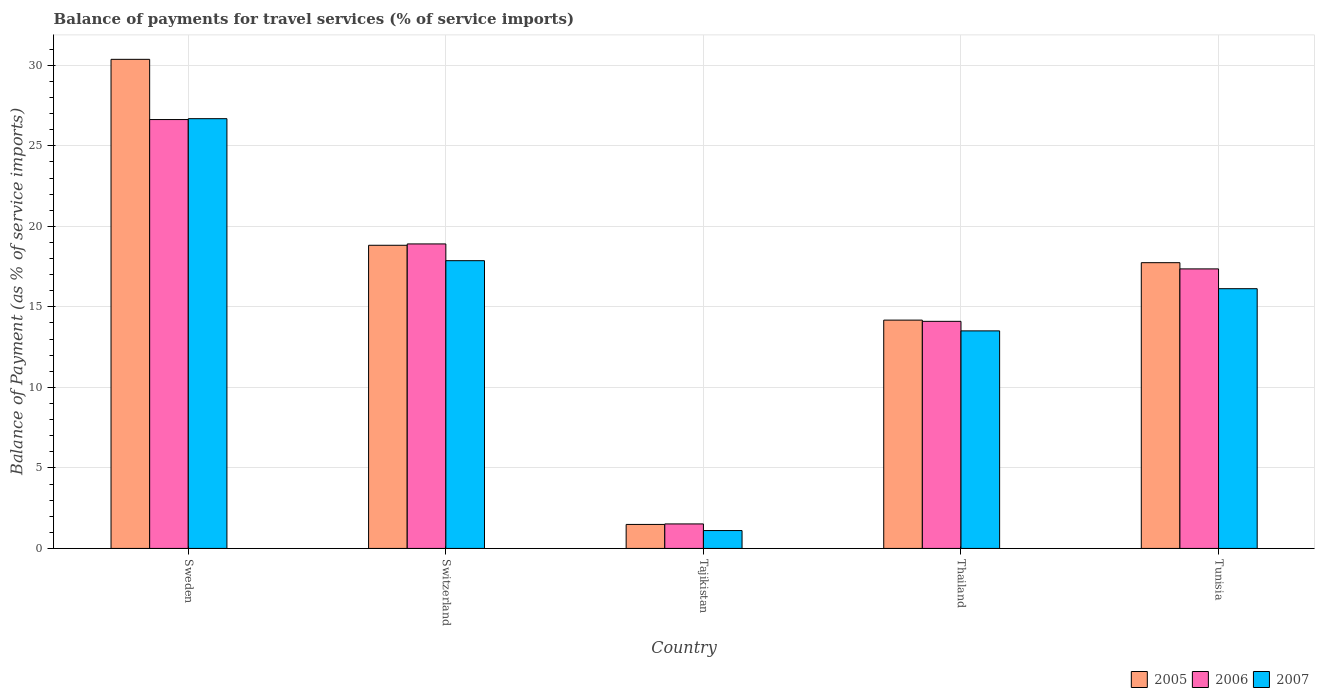How many different coloured bars are there?
Keep it short and to the point. 3. How many groups of bars are there?
Your answer should be very brief. 5. Are the number of bars on each tick of the X-axis equal?
Your response must be concise. Yes. How many bars are there on the 1st tick from the right?
Your response must be concise. 3. What is the label of the 1st group of bars from the left?
Provide a succinct answer. Sweden. What is the balance of payments for travel services in 2005 in Sweden?
Provide a succinct answer. 30.37. Across all countries, what is the maximum balance of payments for travel services in 2005?
Your response must be concise. 30.37. Across all countries, what is the minimum balance of payments for travel services in 2006?
Keep it short and to the point. 1.52. In which country was the balance of payments for travel services in 2006 maximum?
Your answer should be very brief. Sweden. In which country was the balance of payments for travel services in 2007 minimum?
Ensure brevity in your answer.  Tajikistan. What is the total balance of payments for travel services in 2005 in the graph?
Offer a very short reply. 82.62. What is the difference between the balance of payments for travel services in 2005 in Sweden and that in Tunisia?
Offer a very short reply. 12.63. What is the difference between the balance of payments for travel services in 2006 in Tunisia and the balance of payments for travel services in 2007 in Tajikistan?
Offer a terse response. 16.25. What is the average balance of payments for travel services in 2005 per country?
Your response must be concise. 16.52. What is the difference between the balance of payments for travel services of/in 2005 and balance of payments for travel services of/in 2007 in Thailand?
Your answer should be compact. 0.67. What is the ratio of the balance of payments for travel services in 2006 in Thailand to that in Tunisia?
Offer a terse response. 0.81. What is the difference between the highest and the second highest balance of payments for travel services in 2005?
Your response must be concise. -1.08. What is the difference between the highest and the lowest balance of payments for travel services in 2007?
Make the answer very short. 25.58. In how many countries, is the balance of payments for travel services in 2007 greater than the average balance of payments for travel services in 2007 taken over all countries?
Make the answer very short. 3. Is the sum of the balance of payments for travel services in 2006 in Sweden and Tajikistan greater than the maximum balance of payments for travel services in 2005 across all countries?
Ensure brevity in your answer.  No. What does the 1st bar from the left in Tunisia represents?
Give a very brief answer. 2005. What does the 1st bar from the right in Tunisia represents?
Provide a short and direct response. 2007. How many bars are there?
Make the answer very short. 15. Are all the bars in the graph horizontal?
Provide a succinct answer. No. How many countries are there in the graph?
Provide a short and direct response. 5. What is the difference between two consecutive major ticks on the Y-axis?
Give a very brief answer. 5. Does the graph contain any zero values?
Offer a very short reply. No. Does the graph contain grids?
Make the answer very short. Yes. Where does the legend appear in the graph?
Give a very brief answer. Bottom right. What is the title of the graph?
Your response must be concise. Balance of payments for travel services (% of service imports). What is the label or title of the Y-axis?
Provide a succinct answer. Balance of Payment (as % of service imports). What is the Balance of Payment (as % of service imports) in 2005 in Sweden?
Give a very brief answer. 30.37. What is the Balance of Payment (as % of service imports) of 2006 in Sweden?
Keep it short and to the point. 26.63. What is the Balance of Payment (as % of service imports) of 2007 in Sweden?
Keep it short and to the point. 26.69. What is the Balance of Payment (as % of service imports) in 2005 in Switzerland?
Ensure brevity in your answer.  18.83. What is the Balance of Payment (as % of service imports) of 2006 in Switzerland?
Provide a succinct answer. 18.91. What is the Balance of Payment (as % of service imports) of 2007 in Switzerland?
Your answer should be very brief. 17.87. What is the Balance of Payment (as % of service imports) of 2005 in Tajikistan?
Offer a very short reply. 1.49. What is the Balance of Payment (as % of service imports) in 2006 in Tajikistan?
Ensure brevity in your answer.  1.52. What is the Balance of Payment (as % of service imports) in 2007 in Tajikistan?
Offer a terse response. 1.11. What is the Balance of Payment (as % of service imports) of 2005 in Thailand?
Offer a terse response. 14.18. What is the Balance of Payment (as % of service imports) in 2006 in Thailand?
Ensure brevity in your answer.  14.1. What is the Balance of Payment (as % of service imports) of 2007 in Thailand?
Make the answer very short. 13.51. What is the Balance of Payment (as % of service imports) of 2005 in Tunisia?
Your answer should be very brief. 17.75. What is the Balance of Payment (as % of service imports) of 2006 in Tunisia?
Give a very brief answer. 17.36. What is the Balance of Payment (as % of service imports) in 2007 in Tunisia?
Ensure brevity in your answer.  16.13. Across all countries, what is the maximum Balance of Payment (as % of service imports) of 2005?
Offer a terse response. 30.37. Across all countries, what is the maximum Balance of Payment (as % of service imports) of 2006?
Offer a terse response. 26.63. Across all countries, what is the maximum Balance of Payment (as % of service imports) in 2007?
Make the answer very short. 26.69. Across all countries, what is the minimum Balance of Payment (as % of service imports) of 2005?
Your response must be concise. 1.49. Across all countries, what is the minimum Balance of Payment (as % of service imports) in 2006?
Your answer should be compact. 1.52. Across all countries, what is the minimum Balance of Payment (as % of service imports) in 2007?
Keep it short and to the point. 1.11. What is the total Balance of Payment (as % of service imports) of 2005 in the graph?
Your response must be concise. 82.62. What is the total Balance of Payment (as % of service imports) of 2006 in the graph?
Your answer should be compact. 78.53. What is the total Balance of Payment (as % of service imports) in 2007 in the graph?
Provide a short and direct response. 75.31. What is the difference between the Balance of Payment (as % of service imports) of 2005 in Sweden and that in Switzerland?
Give a very brief answer. 11.55. What is the difference between the Balance of Payment (as % of service imports) in 2006 in Sweden and that in Switzerland?
Offer a terse response. 7.72. What is the difference between the Balance of Payment (as % of service imports) in 2007 in Sweden and that in Switzerland?
Your answer should be very brief. 8.82. What is the difference between the Balance of Payment (as % of service imports) of 2005 in Sweden and that in Tajikistan?
Ensure brevity in your answer.  28.88. What is the difference between the Balance of Payment (as % of service imports) in 2006 in Sweden and that in Tajikistan?
Your response must be concise. 25.11. What is the difference between the Balance of Payment (as % of service imports) of 2007 in Sweden and that in Tajikistan?
Provide a succinct answer. 25.58. What is the difference between the Balance of Payment (as % of service imports) of 2005 in Sweden and that in Thailand?
Ensure brevity in your answer.  16.2. What is the difference between the Balance of Payment (as % of service imports) in 2006 in Sweden and that in Thailand?
Keep it short and to the point. 12.53. What is the difference between the Balance of Payment (as % of service imports) in 2007 in Sweden and that in Thailand?
Provide a succinct answer. 13.18. What is the difference between the Balance of Payment (as % of service imports) of 2005 in Sweden and that in Tunisia?
Ensure brevity in your answer.  12.63. What is the difference between the Balance of Payment (as % of service imports) of 2006 in Sweden and that in Tunisia?
Offer a terse response. 9.27. What is the difference between the Balance of Payment (as % of service imports) of 2007 in Sweden and that in Tunisia?
Provide a succinct answer. 10.56. What is the difference between the Balance of Payment (as % of service imports) in 2005 in Switzerland and that in Tajikistan?
Offer a very short reply. 17.34. What is the difference between the Balance of Payment (as % of service imports) in 2006 in Switzerland and that in Tajikistan?
Provide a short and direct response. 17.39. What is the difference between the Balance of Payment (as % of service imports) of 2007 in Switzerland and that in Tajikistan?
Ensure brevity in your answer.  16.76. What is the difference between the Balance of Payment (as % of service imports) of 2005 in Switzerland and that in Thailand?
Your answer should be very brief. 4.65. What is the difference between the Balance of Payment (as % of service imports) in 2006 in Switzerland and that in Thailand?
Provide a short and direct response. 4.81. What is the difference between the Balance of Payment (as % of service imports) of 2007 in Switzerland and that in Thailand?
Your answer should be very brief. 4.36. What is the difference between the Balance of Payment (as % of service imports) of 2005 in Switzerland and that in Tunisia?
Make the answer very short. 1.08. What is the difference between the Balance of Payment (as % of service imports) of 2006 in Switzerland and that in Tunisia?
Keep it short and to the point. 1.55. What is the difference between the Balance of Payment (as % of service imports) in 2007 in Switzerland and that in Tunisia?
Provide a short and direct response. 1.74. What is the difference between the Balance of Payment (as % of service imports) in 2005 in Tajikistan and that in Thailand?
Your answer should be compact. -12.69. What is the difference between the Balance of Payment (as % of service imports) in 2006 in Tajikistan and that in Thailand?
Your response must be concise. -12.58. What is the difference between the Balance of Payment (as % of service imports) in 2007 in Tajikistan and that in Thailand?
Keep it short and to the point. -12.4. What is the difference between the Balance of Payment (as % of service imports) in 2005 in Tajikistan and that in Tunisia?
Your answer should be compact. -16.26. What is the difference between the Balance of Payment (as % of service imports) in 2006 in Tajikistan and that in Tunisia?
Provide a short and direct response. -15.84. What is the difference between the Balance of Payment (as % of service imports) of 2007 in Tajikistan and that in Tunisia?
Provide a succinct answer. -15.02. What is the difference between the Balance of Payment (as % of service imports) of 2005 in Thailand and that in Tunisia?
Offer a very short reply. -3.57. What is the difference between the Balance of Payment (as % of service imports) of 2006 in Thailand and that in Tunisia?
Provide a short and direct response. -3.26. What is the difference between the Balance of Payment (as % of service imports) in 2007 in Thailand and that in Tunisia?
Offer a very short reply. -2.62. What is the difference between the Balance of Payment (as % of service imports) in 2005 in Sweden and the Balance of Payment (as % of service imports) in 2006 in Switzerland?
Offer a terse response. 11.46. What is the difference between the Balance of Payment (as % of service imports) in 2005 in Sweden and the Balance of Payment (as % of service imports) in 2007 in Switzerland?
Your response must be concise. 12.5. What is the difference between the Balance of Payment (as % of service imports) in 2006 in Sweden and the Balance of Payment (as % of service imports) in 2007 in Switzerland?
Offer a terse response. 8.76. What is the difference between the Balance of Payment (as % of service imports) in 2005 in Sweden and the Balance of Payment (as % of service imports) in 2006 in Tajikistan?
Your answer should be very brief. 28.85. What is the difference between the Balance of Payment (as % of service imports) of 2005 in Sweden and the Balance of Payment (as % of service imports) of 2007 in Tajikistan?
Your answer should be compact. 29.26. What is the difference between the Balance of Payment (as % of service imports) in 2006 in Sweden and the Balance of Payment (as % of service imports) in 2007 in Tajikistan?
Your response must be concise. 25.52. What is the difference between the Balance of Payment (as % of service imports) in 2005 in Sweden and the Balance of Payment (as % of service imports) in 2006 in Thailand?
Your answer should be very brief. 16.27. What is the difference between the Balance of Payment (as % of service imports) in 2005 in Sweden and the Balance of Payment (as % of service imports) in 2007 in Thailand?
Ensure brevity in your answer.  16.86. What is the difference between the Balance of Payment (as % of service imports) in 2006 in Sweden and the Balance of Payment (as % of service imports) in 2007 in Thailand?
Your answer should be very brief. 13.12. What is the difference between the Balance of Payment (as % of service imports) in 2005 in Sweden and the Balance of Payment (as % of service imports) in 2006 in Tunisia?
Give a very brief answer. 13.01. What is the difference between the Balance of Payment (as % of service imports) in 2005 in Sweden and the Balance of Payment (as % of service imports) in 2007 in Tunisia?
Your answer should be compact. 14.24. What is the difference between the Balance of Payment (as % of service imports) in 2006 in Sweden and the Balance of Payment (as % of service imports) in 2007 in Tunisia?
Provide a short and direct response. 10.5. What is the difference between the Balance of Payment (as % of service imports) of 2005 in Switzerland and the Balance of Payment (as % of service imports) of 2006 in Tajikistan?
Your response must be concise. 17.3. What is the difference between the Balance of Payment (as % of service imports) of 2005 in Switzerland and the Balance of Payment (as % of service imports) of 2007 in Tajikistan?
Your response must be concise. 17.72. What is the difference between the Balance of Payment (as % of service imports) of 2006 in Switzerland and the Balance of Payment (as % of service imports) of 2007 in Tajikistan?
Your answer should be compact. 17.8. What is the difference between the Balance of Payment (as % of service imports) of 2005 in Switzerland and the Balance of Payment (as % of service imports) of 2006 in Thailand?
Your answer should be very brief. 4.72. What is the difference between the Balance of Payment (as % of service imports) in 2005 in Switzerland and the Balance of Payment (as % of service imports) in 2007 in Thailand?
Offer a very short reply. 5.32. What is the difference between the Balance of Payment (as % of service imports) in 2006 in Switzerland and the Balance of Payment (as % of service imports) in 2007 in Thailand?
Offer a terse response. 5.4. What is the difference between the Balance of Payment (as % of service imports) in 2005 in Switzerland and the Balance of Payment (as % of service imports) in 2006 in Tunisia?
Ensure brevity in your answer.  1.47. What is the difference between the Balance of Payment (as % of service imports) in 2005 in Switzerland and the Balance of Payment (as % of service imports) in 2007 in Tunisia?
Provide a succinct answer. 2.7. What is the difference between the Balance of Payment (as % of service imports) in 2006 in Switzerland and the Balance of Payment (as % of service imports) in 2007 in Tunisia?
Your response must be concise. 2.78. What is the difference between the Balance of Payment (as % of service imports) in 2005 in Tajikistan and the Balance of Payment (as % of service imports) in 2006 in Thailand?
Ensure brevity in your answer.  -12.61. What is the difference between the Balance of Payment (as % of service imports) of 2005 in Tajikistan and the Balance of Payment (as % of service imports) of 2007 in Thailand?
Your answer should be compact. -12.02. What is the difference between the Balance of Payment (as % of service imports) of 2006 in Tajikistan and the Balance of Payment (as % of service imports) of 2007 in Thailand?
Your response must be concise. -11.99. What is the difference between the Balance of Payment (as % of service imports) of 2005 in Tajikistan and the Balance of Payment (as % of service imports) of 2006 in Tunisia?
Ensure brevity in your answer.  -15.87. What is the difference between the Balance of Payment (as % of service imports) in 2005 in Tajikistan and the Balance of Payment (as % of service imports) in 2007 in Tunisia?
Keep it short and to the point. -14.64. What is the difference between the Balance of Payment (as % of service imports) of 2006 in Tajikistan and the Balance of Payment (as % of service imports) of 2007 in Tunisia?
Make the answer very short. -14.61. What is the difference between the Balance of Payment (as % of service imports) of 2005 in Thailand and the Balance of Payment (as % of service imports) of 2006 in Tunisia?
Provide a short and direct response. -3.18. What is the difference between the Balance of Payment (as % of service imports) in 2005 in Thailand and the Balance of Payment (as % of service imports) in 2007 in Tunisia?
Your answer should be very brief. -1.95. What is the difference between the Balance of Payment (as % of service imports) of 2006 in Thailand and the Balance of Payment (as % of service imports) of 2007 in Tunisia?
Your response must be concise. -2.03. What is the average Balance of Payment (as % of service imports) of 2005 per country?
Ensure brevity in your answer.  16.52. What is the average Balance of Payment (as % of service imports) in 2006 per country?
Your response must be concise. 15.71. What is the average Balance of Payment (as % of service imports) of 2007 per country?
Ensure brevity in your answer.  15.06. What is the difference between the Balance of Payment (as % of service imports) in 2005 and Balance of Payment (as % of service imports) in 2006 in Sweden?
Provide a succinct answer. 3.74. What is the difference between the Balance of Payment (as % of service imports) in 2005 and Balance of Payment (as % of service imports) in 2007 in Sweden?
Offer a very short reply. 3.69. What is the difference between the Balance of Payment (as % of service imports) in 2006 and Balance of Payment (as % of service imports) in 2007 in Sweden?
Make the answer very short. -0.06. What is the difference between the Balance of Payment (as % of service imports) in 2005 and Balance of Payment (as % of service imports) in 2006 in Switzerland?
Provide a short and direct response. -0.08. What is the difference between the Balance of Payment (as % of service imports) in 2005 and Balance of Payment (as % of service imports) in 2007 in Switzerland?
Your answer should be very brief. 0.96. What is the difference between the Balance of Payment (as % of service imports) in 2006 and Balance of Payment (as % of service imports) in 2007 in Switzerland?
Give a very brief answer. 1.04. What is the difference between the Balance of Payment (as % of service imports) of 2005 and Balance of Payment (as % of service imports) of 2006 in Tajikistan?
Make the answer very short. -0.03. What is the difference between the Balance of Payment (as % of service imports) of 2005 and Balance of Payment (as % of service imports) of 2007 in Tajikistan?
Provide a succinct answer. 0.38. What is the difference between the Balance of Payment (as % of service imports) in 2006 and Balance of Payment (as % of service imports) in 2007 in Tajikistan?
Provide a succinct answer. 0.41. What is the difference between the Balance of Payment (as % of service imports) of 2005 and Balance of Payment (as % of service imports) of 2006 in Thailand?
Provide a succinct answer. 0.08. What is the difference between the Balance of Payment (as % of service imports) in 2005 and Balance of Payment (as % of service imports) in 2007 in Thailand?
Provide a short and direct response. 0.67. What is the difference between the Balance of Payment (as % of service imports) of 2006 and Balance of Payment (as % of service imports) of 2007 in Thailand?
Offer a very short reply. 0.59. What is the difference between the Balance of Payment (as % of service imports) of 2005 and Balance of Payment (as % of service imports) of 2006 in Tunisia?
Provide a short and direct response. 0.39. What is the difference between the Balance of Payment (as % of service imports) in 2005 and Balance of Payment (as % of service imports) in 2007 in Tunisia?
Make the answer very short. 1.62. What is the difference between the Balance of Payment (as % of service imports) of 2006 and Balance of Payment (as % of service imports) of 2007 in Tunisia?
Your answer should be compact. 1.23. What is the ratio of the Balance of Payment (as % of service imports) in 2005 in Sweden to that in Switzerland?
Keep it short and to the point. 1.61. What is the ratio of the Balance of Payment (as % of service imports) in 2006 in Sweden to that in Switzerland?
Your answer should be compact. 1.41. What is the ratio of the Balance of Payment (as % of service imports) in 2007 in Sweden to that in Switzerland?
Give a very brief answer. 1.49. What is the ratio of the Balance of Payment (as % of service imports) of 2005 in Sweden to that in Tajikistan?
Offer a terse response. 20.38. What is the ratio of the Balance of Payment (as % of service imports) in 2006 in Sweden to that in Tajikistan?
Your answer should be compact. 17.5. What is the ratio of the Balance of Payment (as % of service imports) in 2007 in Sweden to that in Tajikistan?
Give a very brief answer. 24.04. What is the ratio of the Balance of Payment (as % of service imports) of 2005 in Sweden to that in Thailand?
Ensure brevity in your answer.  2.14. What is the ratio of the Balance of Payment (as % of service imports) of 2006 in Sweden to that in Thailand?
Offer a terse response. 1.89. What is the ratio of the Balance of Payment (as % of service imports) of 2007 in Sweden to that in Thailand?
Keep it short and to the point. 1.98. What is the ratio of the Balance of Payment (as % of service imports) of 2005 in Sweden to that in Tunisia?
Offer a terse response. 1.71. What is the ratio of the Balance of Payment (as % of service imports) of 2006 in Sweden to that in Tunisia?
Offer a very short reply. 1.53. What is the ratio of the Balance of Payment (as % of service imports) of 2007 in Sweden to that in Tunisia?
Ensure brevity in your answer.  1.65. What is the ratio of the Balance of Payment (as % of service imports) of 2005 in Switzerland to that in Tajikistan?
Make the answer very short. 12.63. What is the ratio of the Balance of Payment (as % of service imports) of 2006 in Switzerland to that in Tajikistan?
Provide a succinct answer. 12.42. What is the ratio of the Balance of Payment (as % of service imports) of 2007 in Switzerland to that in Tajikistan?
Provide a short and direct response. 16.09. What is the ratio of the Balance of Payment (as % of service imports) of 2005 in Switzerland to that in Thailand?
Ensure brevity in your answer.  1.33. What is the ratio of the Balance of Payment (as % of service imports) in 2006 in Switzerland to that in Thailand?
Your answer should be very brief. 1.34. What is the ratio of the Balance of Payment (as % of service imports) in 2007 in Switzerland to that in Thailand?
Ensure brevity in your answer.  1.32. What is the ratio of the Balance of Payment (as % of service imports) of 2005 in Switzerland to that in Tunisia?
Ensure brevity in your answer.  1.06. What is the ratio of the Balance of Payment (as % of service imports) of 2006 in Switzerland to that in Tunisia?
Make the answer very short. 1.09. What is the ratio of the Balance of Payment (as % of service imports) in 2007 in Switzerland to that in Tunisia?
Offer a very short reply. 1.11. What is the ratio of the Balance of Payment (as % of service imports) of 2005 in Tajikistan to that in Thailand?
Your answer should be compact. 0.11. What is the ratio of the Balance of Payment (as % of service imports) in 2006 in Tajikistan to that in Thailand?
Provide a succinct answer. 0.11. What is the ratio of the Balance of Payment (as % of service imports) in 2007 in Tajikistan to that in Thailand?
Your answer should be very brief. 0.08. What is the ratio of the Balance of Payment (as % of service imports) in 2005 in Tajikistan to that in Tunisia?
Your answer should be very brief. 0.08. What is the ratio of the Balance of Payment (as % of service imports) in 2006 in Tajikistan to that in Tunisia?
Your answer should be very brief. 0.09. What is the ratio of the Balance of Payment (as % of service imports) in 2007 in Tajikistan to that in Tunisia?
Give a very brief answer. 0.07. What is the ratio of the Balance of Payment (as % of service imports) in 2005 in Thailand to that in Tunisia?
Your answer should be very brief. 0.8. What is the ratio of the Balance of Payment (as % of service imports) of 2006 in Thailand to that in Tunisia?
Provide a short and direct response. 0.81. What is the ratio of the Balance of Payment (as % of service imports) of 2007 in Thailand to that in Tunisia?
Offer a very short reply. 0.84. What is the difference between the highest and the second highest Balance of Payment (as % of service imports) of 2005?
Your answer should be compact. 11.55. What is the difference between the highest and the second highest Balance of Payment (as % of service imports) in 2006?
Provide a succinct answer. 7.72. What is the difference between the highest and the second highest Balance of Payment (as % of service imports) of 2007?
Your response must be concise. 8.82. What is the difference between the highest and the lowest Balance of Payment (as % of service imports) of 2005?
Provide a succinct answer. 28.88. What is the difference between the highest and the lowest Balance of Payment (as % of service imports) of 2006?
Ensure brevity in your answer.  25.11. What is the difference between the highest and the lowest Balance of Payment (as % of service imports) in 2007?
Make the answer very short. 25.58. 